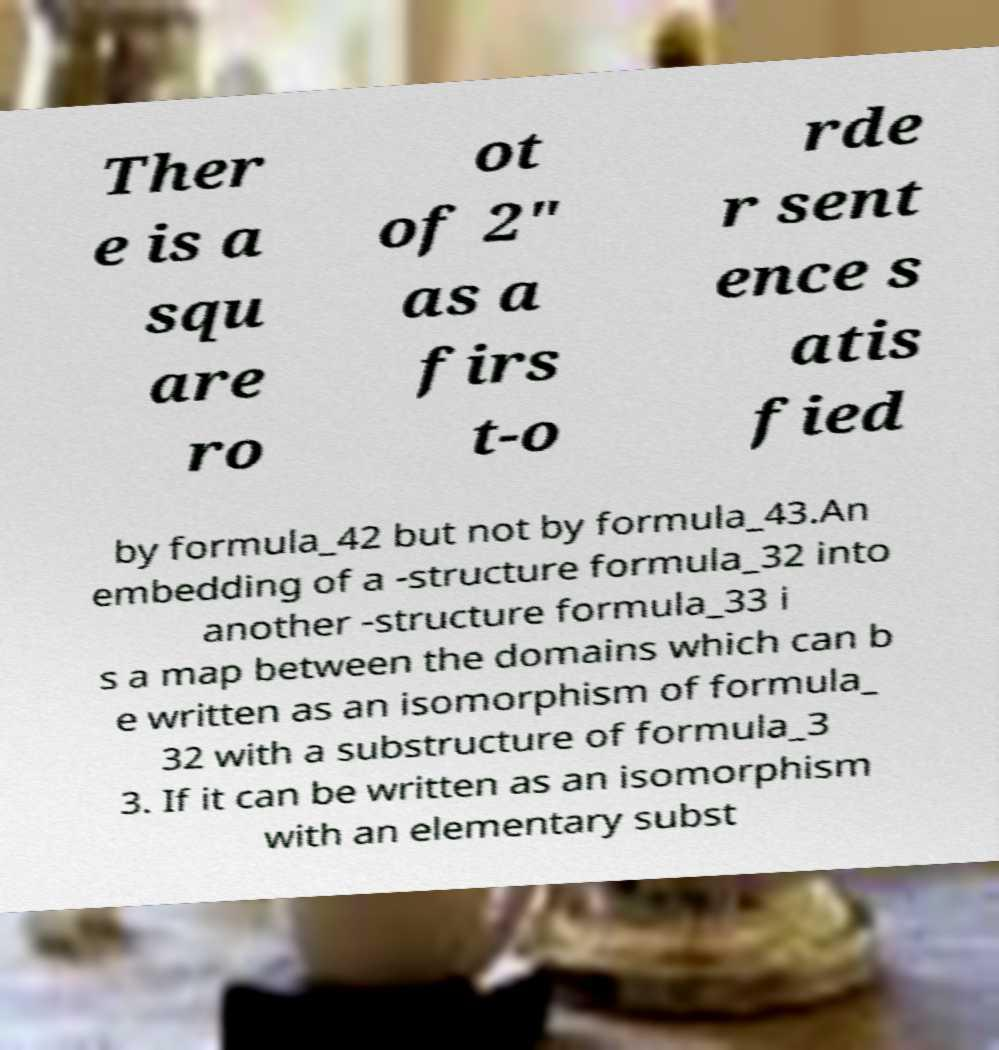Please identify and transcribe the text found in this image. Ther e is a squ are ro ot of 2" as a firs t-o rde r sent ence s atis fied by formula_42 but not by formula_43.An embedding of a -structure formula_32 into another -structure formula_33 i s a map between the domains which can b e written as an isomorphism of formula_ 32 with a substructure of formula_3 3. If it can be written as an isomorphism with an elementary subst 